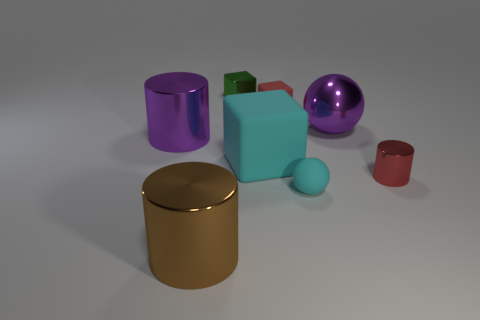Subtract all tiny red cubes. How many cubes are left? 2 Add 2 gray cubes. How many objects exist? 10 Subtract all green cubes. How many cubes are left? 2 Subtract all metal cubes. Subtract all small green shiny things. How many objects are left? 6 Add 5 red blocks. How many red blocks are left? 6 Add 4 large red rubber spheres. How many large red rubber spheres exist? 4 Subtract 0 purple cubes. How many objects are left? 8 Subtract all balls. How many objects are left? 6 Subtract 1 cylinders. How many cylinders are left? 2 Subtract all blue blocks. Subtract all cyan cylinders. How many blocks are left? 3 